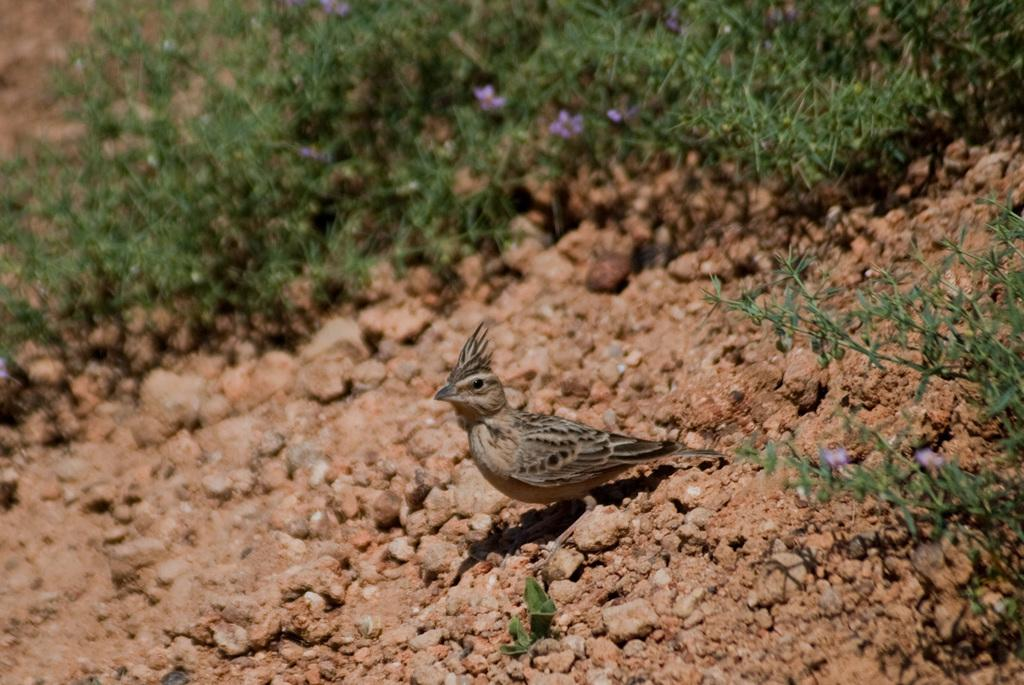What type of animal can be seen in the image? There is a bird in the image. What else is present in the image besides the bird? There are plants in the image. Can you describe the plants in the image? The plants have flowers on them. What type of wrench is being used to water the plants in the image? There is no wrench present in the image, and the plants are not being watered. 